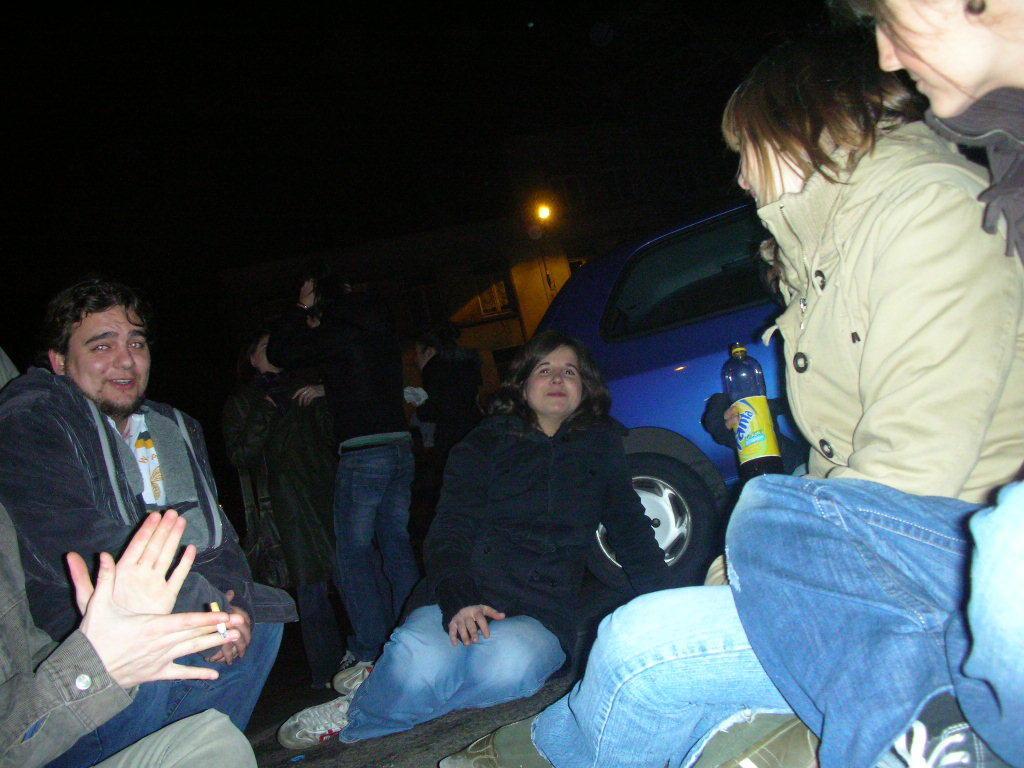In one or two sentences, can you explain what this image depicts? In this picture we can observe some people sitting. There are women and a man. In the background there are some people standing. We can observe blue color car here. There is a building and a light in the background. 